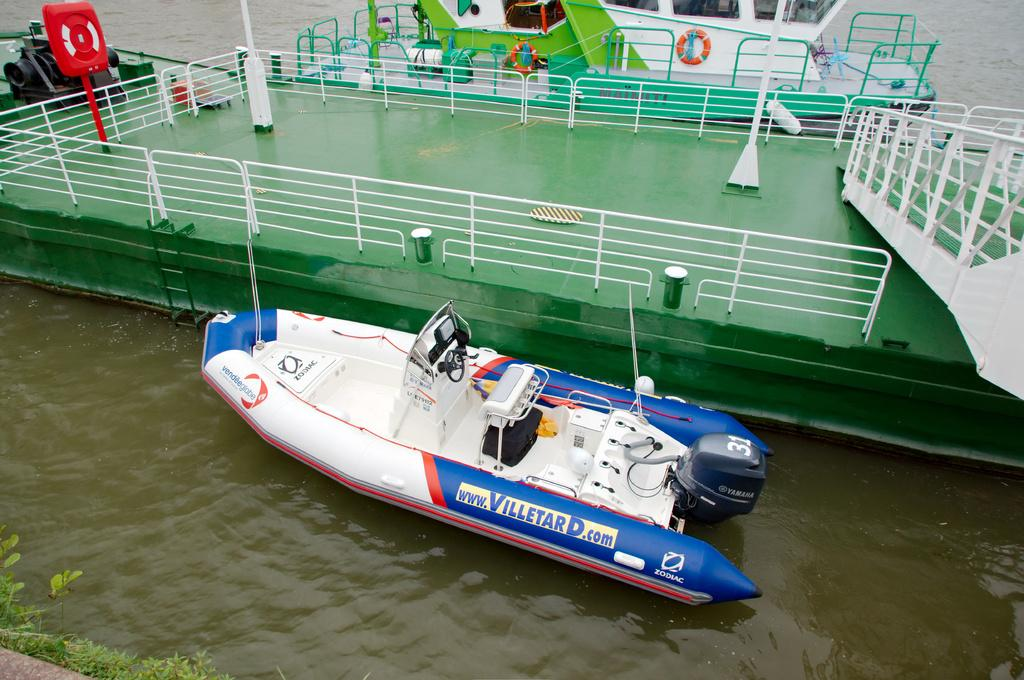What is located on the surface of the water in the image? There is a boat on the surface of the water in the image. Where is the boat positioned in relation to the image? The boat is visible at the bottom of the image. What structure can be seen in the middle of the image? There is a dock in the middle of the image. What type of representative can be seen holding a jar in the image? There is no representative or jar present in the image; it features a boat on the water and a dock. 